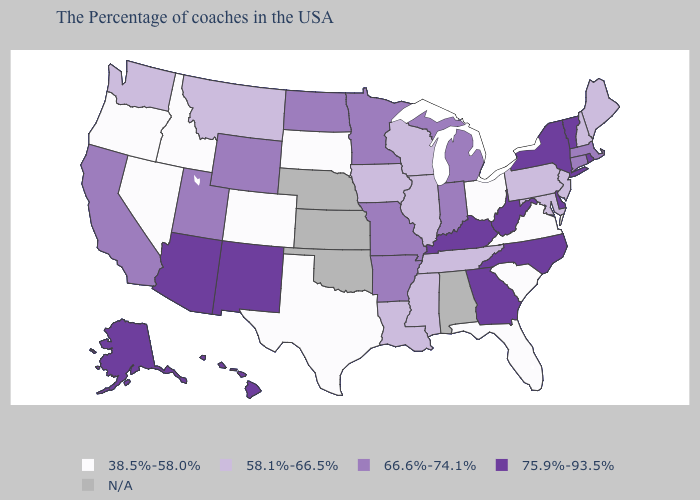What is the highest value in the USA?
Give a very brief answer. 75.9%-93.5%. What is the value of Washington?
Answer briefly. 58.1%-66.5%. What is the value of Oklahoma?
Keep it brief. N/A. What is the lowest value in states that border Maine?
Keep it brief. 58.1%-66.5%. What is the value of Nevada?
Write a very short answer. 38.5%-58.0%. What is the highest value in the Northeast ?
Concise answer only. 75.9%-93.5%. What is the lowest value in the USA?
Short answer required. 38.5%-58.0%. Which states have the lowest value in the USA?
Keep it brief. Virginia, South Carolina, Ohio, Florida, Texas, South Dakota, Colorado, Idaho, Nevada, Oregon. What is the highest value in the Northeast ?
Short answer required. 75.9%-93.5%. Among the states that border Virginia , which have the lowest value?
Write a very short answer. Maryland, Tennessee. Does Montana have the highest value in the West?
Short answer required. No. Does Rhode Island have the highest value in the Northeast?
Quick response, please. Yes. Name the states that have a value in the range 66.6%-74.1%?
Short answer required. Massachusetts, Connecticut, Michigan, Indiana, Missouri, Arkansas, Minnesota, North Dakota, Wyoming, Utah, California. 